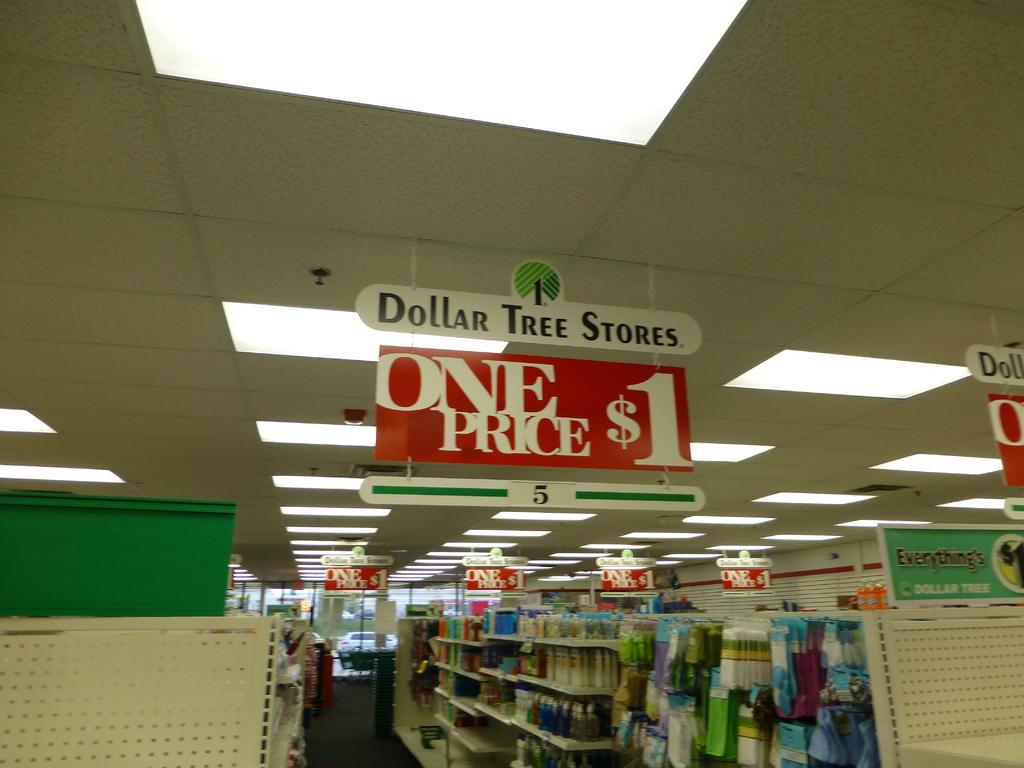<image>
Offer a succinct explanation of the picture presented. Aisle of a Dollar Tree Store selling things for $1. 